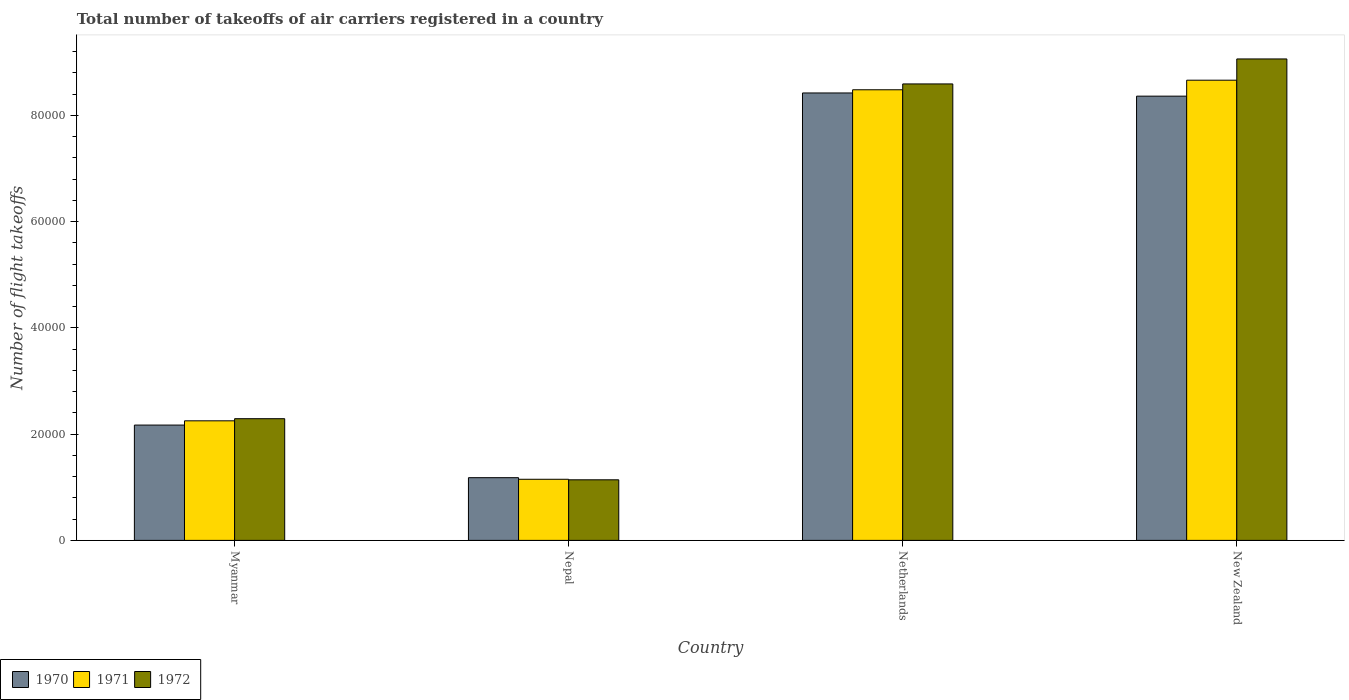How many different coloured bars are there?
Keep it short and to the point. 3. How many bars are there on the 4th tick from the left?
Keep it short and to the point. 3. How many bars are there on the 3rd tick from the right?
Offer a terse response. 3. What is the label of the 1st group of bars from the left?
Offer a terse response. Myanmar. What is the total number of flight takeoffs in 1971 in New Zealand?
Offer a terse response. 8.66e+04. Across all countries, what is the maximum total number of flight takeoffs in 1971?
Make the answer very short. 8.66e+04. Across all countries, what is the minimum total number of flight takeoffs in 1971?
Make the answer very short. 1.15e+04. In which country was the total number of flight takeoffs in 1971 maximum?
Keep it short and to the point. New Zealand. In which country was the total number of flight takeoffs in 1971 minimum?
Provide a short and direct response. Nepal. What is the total total number of flight takeoffs in 1970 in the graph?
Your response must be concise. 2.01e+05. What is the difference between the total number of flight takeoffs in 1971 in Myanmar and that in Netherlands?
Your response must be concise. -6.23e+04. What is the difference between the total number of flight takeoffs in 1972 in New Zealand and the total number of flight takeoffs in 1970 in Netherlands?
Your answer should be compact. 6400. What is the average total number of flight takeoffs in 1971 per country?
Ensure brevity in your answer.  5.14e+04. What is the difference between the total number of flight takeoffs of/in 1970 and total number of flight takeoffs of/in 1972 in Myanmar?
Offer a very short reply. -1200. In how many countries, is the total number of flight takeoffs in 1970 greater than 88000?
Your answer should be very brief. 0. What is the ratio of the total number of flight takeoffs in 1971 in Myanmar to that in New Zealand?
Your answer should be compact. 0.26. Is the difference between the total number of flight takeoffs in 1970 in Nepal and Netherlands greater than the difference between the total number of flight takeoffs in 1972 in Nepal and Netherlands?
Offer a very short reply. Yes. What is the difference between the highest and the second highest total number of flight takeoffs in 1972?
Your answer should be compact. 4700. What is the difference between the highest and the lowest total number of flight takeoffs in 1972?
Your answer should be compact. 7.92e+04. Is the sum of the total number of flight takeoffs in 1971 in Myanmar and Netherlands greater than the maximum total number of flight takeoffs in 1970 across all countries?
Your answer should be very brief. Yes. What does the 3rd bar from the left in New Zealand represents?
Provide a short and direct response. 1972. How many countries are there in the graph?
Ensure brevity in your answer.  4. Are the values on the major ticks of Y-axis written in scientific E-notation?
Your response must be concise. No. Does the graph contain grids?
Keep it short and to the point. No. Where does the legend appear in the graph?
Your answer should be compact. Bottom left. How are the legend labels stacked?
Ensure brevity in your answer.  Horizontal. What is the title of the graph?
Provide a short and direct response. Total number of takeoffs of air carriers registered in a country. What is the label or title of the Y-axis?
Provide a succinct answer. Number of flight takeoffs. What is the Number of flight takeoffs in 1970 in Myanmar?
Your response must be concise. 2.17e+04. What is the Number of flight takeoffs in 1971 in Myanmar?
Your answer should be very brief. 2.25e+04. What is the Number of flight takeoffs in 1972 in Myanmar?
Offer a very short reply. 2.29e+04. What is the Number of flight takeoffs of 1970 in Nepal?
Offer a very short reply. 1.18e+04. What is the Number of flight takeoffs in 1971 in Nepal?
Make the answer very short. 1.15e+04. What is the Number of flight takeoffs in 1972 in Nepal?
Your answer should be compact. 1.14e+04. What is the Number of flight takeoffs of 1970 in Netherlands?
Make the answer very short. 8.42e+04. What is the Number of flight takeoffs of 1971 in Netherlands?
Keep it short and to the point. 8.48e+04. What is the Number of flight takeoffs of 1972 in Netherlands?
Ensure brevity in your answer.  8.59e+04. What is the Number of flight takeoffs of 1970 in New Zealand?
Give a very brief answer. 8.36e+04. What is the Number of flight takeoffs of 1971 in New Zealand?
Your answer should be compact. 8.66e+04. What is the Number of flight takeoffs in 1972 in New Zealand?
Your answer should be very brief. 9.06e+04. Across all countries, what is the maximum Number of flight takeoffs in 1970?
Your answer should be very brief. 8.42e+04. Across all countries, what is the maximum Number of flight takeoffs in 1971?
Keep it short and to the point. 8.66e+04. Across all countries, what is the maximum Number of flight takeoffs in 1972?
Give a very brief answer. 9.06e+04. Across all countries, what is the minimum Number of flight takeoffs of 1970?
Provide a short and direct response. 1.18e+04. Across all countries, what is the minimum Number of flight takeoffs of 1971?
Give a very brief answer. 1.15e+04. Across all countries, what is the minimum Number of flight takeoffs in 1972?
Ensure brevity in your answer.  1.14e+04. What is the total Number of flight takeoffs of 1970 in the graph?
Provide a short and direct response. 2.01e+05. What is the total Number of flight takeoffs in 1971 in the graph?
Offer a very short reply. 2.05e+05. What is the total Number of flight takeoffs in 1972 in the graph?
Your answer should be very brief. 2.11e+05. What is the difference between the Number of flight takeoffs of 1970 in Myanmar and that in Nepal?
Provide a succinct answer. 9900. What is the difference between the Number of flight takeoffs of 1971 in Myanmar and that in Nepal?
Offer a very short reply. 1.10e+04. What is the difference between the Number of flight takeoffs of 1972 in Myanmar and that in Nepal?
Provide a short and direct response. 1.15e+04. What is the difference between the Number of flight takeoffs in 1970 in Myanmar and that in Netherlands?
Your response must be concise. -6.25e+04. What is the difference between the Number of flight takeoffs in 1971 in Myanmar and that in Netherlands?
Offer a terse response. -6.23e+04. What is the difference between the Number of flight takeoffs of 1972 in Myanmar and that in Netherlands?
Give a very brief answer. -6.30e+04. What is the difference between the Number of flight takeoffs of 1970 in Myanmar and that in New Zealand?
Provide a short and direct response. -6.19e+04. What is the difference between the Number of flight takeoffs of 1971 in Myanmar and that in New Zealand?
Your answer should be compact. -6.41e+04. What is the difference between the Number of flight takeoffs of 1972 in Myanmar and that in New Zealand?
Provide a succinct answer. -6.77e+04. What is the difference between the Number of flight takeoffs in 1970 in Nepal and that in Netherlands?
Ensure brevity in your answer.  -7.24e+04. What is the difference between the Number of flight takeoffs in 1971 in Nepal and that in Netherlands?
Your answer should be compact. -7.33e+04. What is the difference between the Number of flight takeoffs in 1972 in Nepal and that in Netherlands?
Your response must be concise. -7.45e+04. What is the difference between the Number of flight takeoffs in 1970 in Nepal and that in New Zealand?
Your answer should be compact. -7.18e+04. What is the difference between the Number of flight takeoffs of 1971 in Nepal and that in New Zealand?
Your answer should be very brief. -7.51e+04. What is the difference between the Number of flight takeoffs of 1972 in Nepal and that in New Zealand?
Offer a very short reply. -7.92e+04. What is the difference between the Number of flight takeoffs of 1970 in Netherlands and that in New Zealand?
Offer a very short reply. 600. What is the difference between the Number of flight takeoffs of 1971 in Netherlands and that in New Zealand?
Keep it short and to the point. -1800. What is the difference between the Number of flight takeoffs of 1972 in Netherlands and that in New Zealand?
Offer a terse response. -4700. What is the difference between the Number of flight takeoffs of 1970 in Myanmar and the Number of flight takeoffs of 1971 in Nepal?
Your answer should be compact. 1.02e+04. What is the difference between the Number of flight takeoffs in 1970 in Myanmar and the Number of flight takeoffs in 1972 in Nepal?
Ensure brevity in your answer.  1.03e+04. What is the difference between the Number of flight takeoffs in 1971 in Myanmar and the Number of flight takeoffs in 1972 in Nepal?
Give a very brief answer. 1.11e+04. What is the difference between the Number of flight takeoffs in 1970 in Myanmar and the Number of flight takeoffs in 1971 in Netherlands?
Make the answer very short. -6.31e+04. What is the difference between the Number of flight takeoffs in 1970 in Myanmar and the Number of flight takeoffs in 1972 in Netherlands?
Offer a very short reply. -6.42e+04. What is the difference between the Number of flight takeoffs in 1971 in Myanmar and the Number of flight takeoffs in 1972 in Netherlands?
Provide a short and direct response. -6.34e+04. What is the difference between the Number of flight takeoffs in 1970 in Myanmar and the Number of flight takeoffs in 1971 in New Zealand?
Your answer should be compact. -6.49e+04. What is the difference between the Number of flight takeoffs in 1970 in Myanmar and the Number of flight takeoffs in 1972 in New Zealand?
Offer a very short reply. -6.89e+04. What is the difference between the Number of flight takeoffs of 1971 in Myanmar and the Number of flight takeoffs of 1972 in New Zealand?
Your response must be concise. -6.81e+04. What is the difference between the Number of flight takeoffs in 1970 in Nepal and the Number of flight takeoffs in 1971 in Netherlands?
Offer a very short reply. -7.30e+04. What is the difference between the Number of flight takeoffs of 1970 in Nepal and the Number of flight takeoffs of 1972 in Netherlands?
Ensure brevity in your answer.  -7.41e+04. What is the difference between the Number of flight takeoffs in 1971 in Nepal and the Number of flight takeoffs in 1972 in Netherlands?
Offer a terse response. -7.44e+04. What is the difference between the Number of flight takeoffs of 1970 in Nepal and the Number of flight takeoffs of 1971 in New Zealand?
Keep it short and to the point. -7.48e+04. What is the difference between the Number of flight takeoffs in 1970 in Nepal and the Number of flight takeoffs in 1972 in New Zealand?
Provide a short and direct response. -7.88e+04. What is the difference between the Number of flight takeoffs of 1971 in Nepal and the Number of flight takeoffs of 1972 in New Zealand?
Your response must be concise. -7.91e+04. What is the difference between the Number of flight takeoffs of 1970 in Netherlands and the Number of flight takeoffs of 1971 in New Zealand?
Provide a short and direct response. -2400. What is the difference between the Number of flight takeoffs of 1970 in Netherlands and the Number of flight takeoffs of 1972 in New Zealand?
Offer a very short reply. -6400. What is the difference between the Number of flight takeoffs in 1971 in Netherlands and the Number of flight takeoffs in 1972 in New Zealand?
Provide a short and direct response. -5800. What is the average Number of flight takeoffs in 1970 per country?
Provide a succinct answer. 5.03e+04. What is the average Number of flight takeoffs in 1971 per country?
Keep it short and to the point. 5.14e+04. What is the average Number of flight takeoffs of 1972 per country?
Provide a succinct answer. 5.27e+04. What is the difference between the Number of flight takeoffs in 1970 and Number of flight takeoffs in 1971 in Myanmar?
Keep it short and to the point. -800. What is the difference between the Number of flight takeoffs of 1970 and Number of flight takeoffs of 1972 in Myanmar?
Your response must be concise. -1200. What is the difference between the Number of flight takeoffs in 1971 and Number of flight takeoffs in 1972 in Myanmar?
Ensure brevity in your answer.  -400. What is the difference between the Number of flight takeoffs of 1970 and Number of flight takeoffs of 1971 in Nepal?
Make the answer very short. 300. What is the difference between the Number of flight takeoffs in 1970 and Number of flight takeoffs in 1972 in Nepal?
Give a very brief answer. 400. What is the difference between the Number of flight takeoffs of 1970 and Number of flight takeoffs of 1971 in Netherlands?
Your answer should be compact. -600. What is the difference between the Number of flight takeoffs in 1970 and Number of flight takeoffs in 1972 in Netherlands?
Your answer should be very brief. -1700. What is the difference between the Number of flight takeoffs of 1971 and Number of flight takeoffs of 1972 in Netherlands?
Provide a succinct answer. -1100. What is the difference between the Number of flight takeoffs of 1970 and Number of flight takeoffs of 1971 in New Zealand?
Your answer should be compact. -3000. What is the difference between the Number of flight takeoffs in 1970 and Number of flight takeoffs in 1972 in New Zealand?
Provide a succinct answer. -7000. What is the difference between the Number of flight takeoffs of 1971 and Number of flight takeoffs of 1972 in New Zealand?
Offer a very short reply. -4000. What is the ratio of the Number of flight takeoffs in 1970 in Myanmar to that in Nepal?
Offer a very short reply. 1.84. What is the ratio of the Number of flight takeoffs in 1971 in Myanmar to that in Nepal?
Offer a very short reply. 1.96. What is the ratio of the Number of flight takeoffs in 1972 in Myanmar to that in Nepal?
Give a very brief answer. 2.01. What is the ratio of the Number of flight takeoffs of 1970 in Myanmar to that in Netherlands?
Keep it short and to the point. 0.26. What is the ratio of the Number of flight takeoffs of 1971 in Myanmar to that in Netherlands?
Provide a succinct answer. 0.27. What is the ratio of the Number of flight takeoffs of 1972 in Myanmar to that in Netherlands?
Your response must be concise. 0.27. What is the ratio of the Number of flight takeoffs of 1970 in Myanmar to that in New Zealand?
Make the answer very short. 0.26. What is the ratio of the Number of flight takeoffs in 1971 in Myanmar to that in New Zealand?
Give a very brief answer. 0.26. What is the ratio of the Number of flight takeoffs in 1972 in Myanmar to that in New Zealand?
Offer a very short reply. 0.25. What is the ratio of the Number of flight takeoffs of 1970 in Nepal to that in Netherlands?
Your response must be concise. 0.14. What is the ratio of the Number of flight takeoffs in 1971 in Nepal to that in Netherlands?
Keep it short and to the point. 0.14. What is the ratio of the Number of flight takeoffs of 1972 in Nepal to that in Netherlands?
Your answer should be very brief. 0.13. What is the ratio of the Number of flight takeoffs of 1970 in Nepal to that in New Zealand?
Provide a succinct answer. 0.14. What is the ratio of the Number of flight takeoffs of 1971 in Nepal to that in New Zealand?
Provide a succinct answer. 0.13. What is the ratio of the Number of flight takeoffs in 1972 in Nepal to that in New Zealand?
Offer a very short reply. 0.13. What is the ratio of the Number of flight takeoffs of 1971 in Netherlands to that in New Zealand?
Offer a very short reply. 0.98. What is the ratio of the Number of flight takeoffs in 1972 in Netherlands to that in New Zealand?
Make the answer very short. 0.95. What is the difference between the highest and the second highest Number of flight takeoffs of 1970?
Provide a succinct answer. 600. What is the difference between the highest and the second highest Number of flight takeoffs in 1971?
Your answer should be very brief. 1800. What is the difference between the highest and the second highest Number of flight takeoffs in 1972?
Provide a succinct answer. 4700. What is the difference between the highest and the lowest Number of flight takeoffs of 1970?
Provide a succinct answer. 7.24e+04. What is the difference between the highest and the lowest Number of flight takeoffs in 1971?
Make the answer very short. 7.51e+04. What is the difference between the highest and the lowest Number of flight takeoffs in 1972?
Your response must be concise. 7.92e+04. 